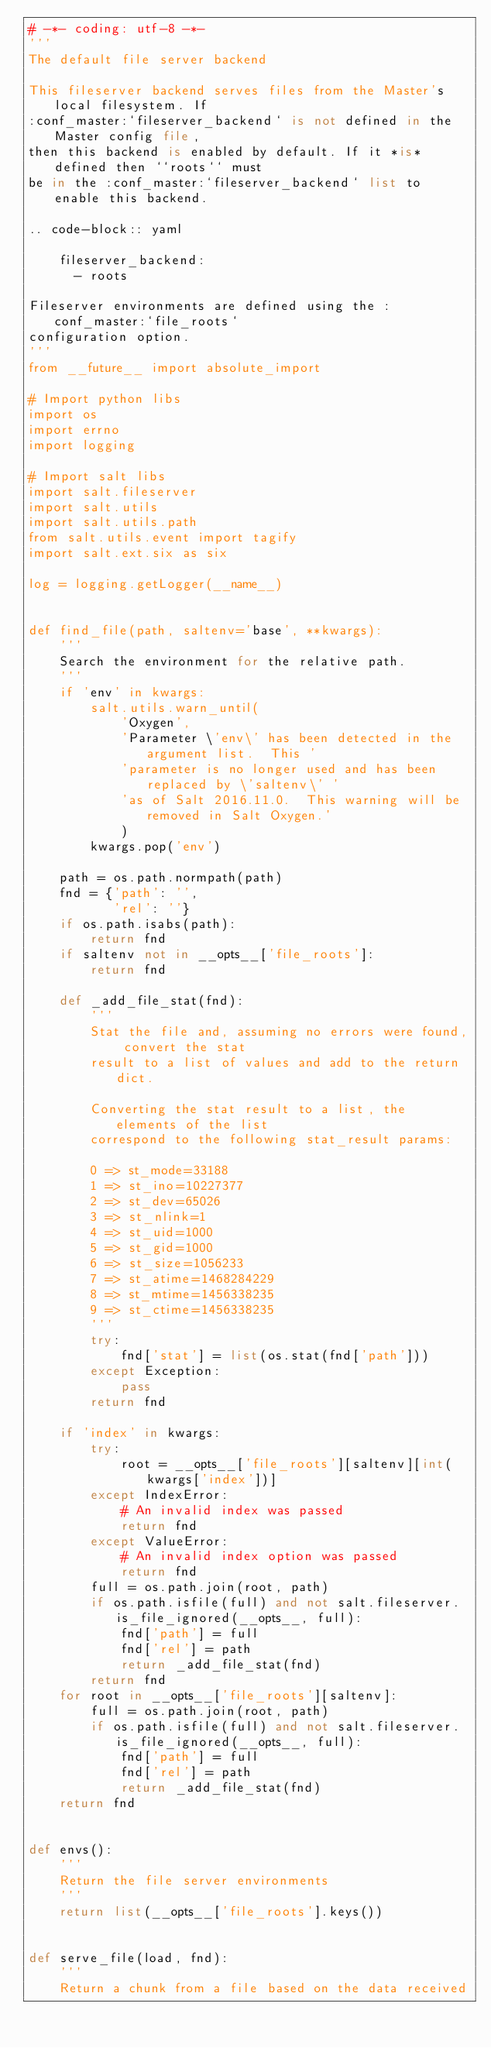<code> <loc_0><loc_0><loc_500><loc_500><_Python_># -*- coding: utf-8 -*-
'''
The default file server backend

This fileserver backend serves files from the Master's local filesystem. If
:conf_master:`fileserver_backend` is not defined in the Master config file,
then this backend is enabled by default. If it *is* defined then ``roots`` must
be in the :conf_master:`fileserver_backend` list to enable this backend.

.. code-block:: yaml

    fileserver_backend:
      - roots

Fileserver environments are defined using the :conf_master:`file_roots`
configuration option.
'''
from __future__ import absolute_import

# Import python libs
import os
import errno
import logging

# Import salt libs
import salt.fileserver
import salt.utils
import salt.utils.path
from salt.utils.event import tagify
import salt.ext.six as six

log = logging.getLogger(__name__)


def find_file(path, saltenv='base', **kwargs):
    '''
    Search the environment for the relative path.
    '''
    if 'env' in kwargs:
        salt.utils.warn_until(
            'Oxygen',
            'Parameter \'env\' has been detected in the argument list.  This '
            'parameter is no longer used and has been replaced by \'saltenv\' '
            'as of Salt 2016.11.0.  This warning will be removed in Salt Oxygen.'
            )
        kwargs.pop('env')

    path = os.path.normpath(path)
    fnd = {'path': '',
           'rel': ''}
    if os.path.isabs(path):
        return fnd
    if saltenv not in __opts__['file_roots']:
        return fnd

    def _add_file_stat(fnd):
        '''
        Stat the file and, assuming no errors were found, convert the stat
        result to a list of values and add to the return dict.

        Converting the stat result to a list, the elements of the list
        correspond to the following stat_result params:

        0 => st_mode=33188
        1 => st_ino=10227377
        2 => st_dev=65026
        3 => st_nlink=1
        4 => st_uid=1000
        5 => st_gid=1000
        6 => st_size=1056233
        7 => st_atime=1468284229
        8 => st_mtime=1456338235
        9 => st_ctime=1456338235
        '''
        try:
            fnd['stat'] = list(os.stat(fnd['path']))
        except Exception:
            pass
        return fnd

    if 'index' in kwargs:
        try:
            root = __opts__['file_roots'][saltenv][int(kwargs['index'])]
        except IndexError:
            # An invalid index was passed
            return fnd
        except ValueError:
            # An invalid index option was passed
            return fnd
        full = os.path.join(root, path)
        if os.path.isfile(full) and not salt.fileserver.is_file_ignored(__opts__, full):
            fnd['path'] = full
            fnd['rel'] = path
            return _add_file_stat(fnd)
        return fnd
    for root in __opts__['file_roots'][saltenv]:
        full = os.path.join(root, path)
        if os.path.isfile(full) and not salt.fileserver.is_file_ignored(__opts__, full):
            fnd['path'] = full
            fnd['rel'] = path
            return _add_file_stat(fnd)
    return fnd


def envs():
    '''
    Return the file server environments
    '''
    return list(__opts__['file_roots'].keys())


def serve_file(load, fnd):
    '''
    Return a chunk from a file based on the data received</code> 